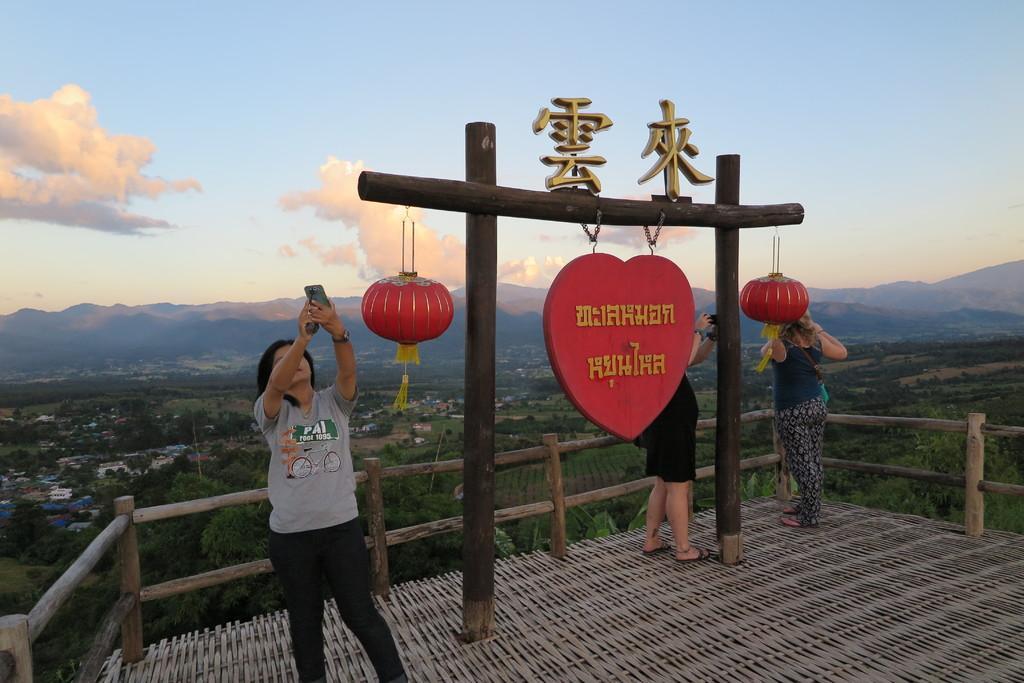Please provide a concise description of this image. In this image I can see three people are standing. In the background, I can see trees, houses and clouds in the sky. 